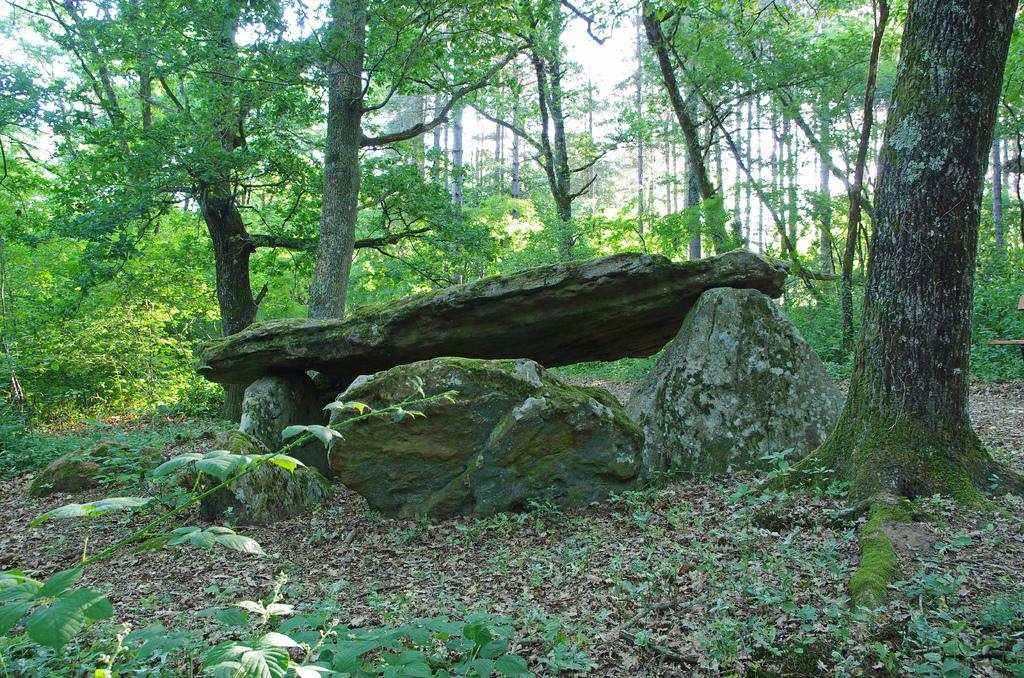What is located in the center of the image? There are rocks in the center of the image. What can be seen in the background of the image? There are trees and plants in the background of the image. Are there any plants visible at the bottom of the image? Yes, there are plants at the bottom of the image. What else can be found at the bottom of the image? Dry leaves are present at the bottom of the image. What type of nail can be seen in the image? There is no nail present in the image. Is there a knee visible in the image? There is no knee visible in the image. 